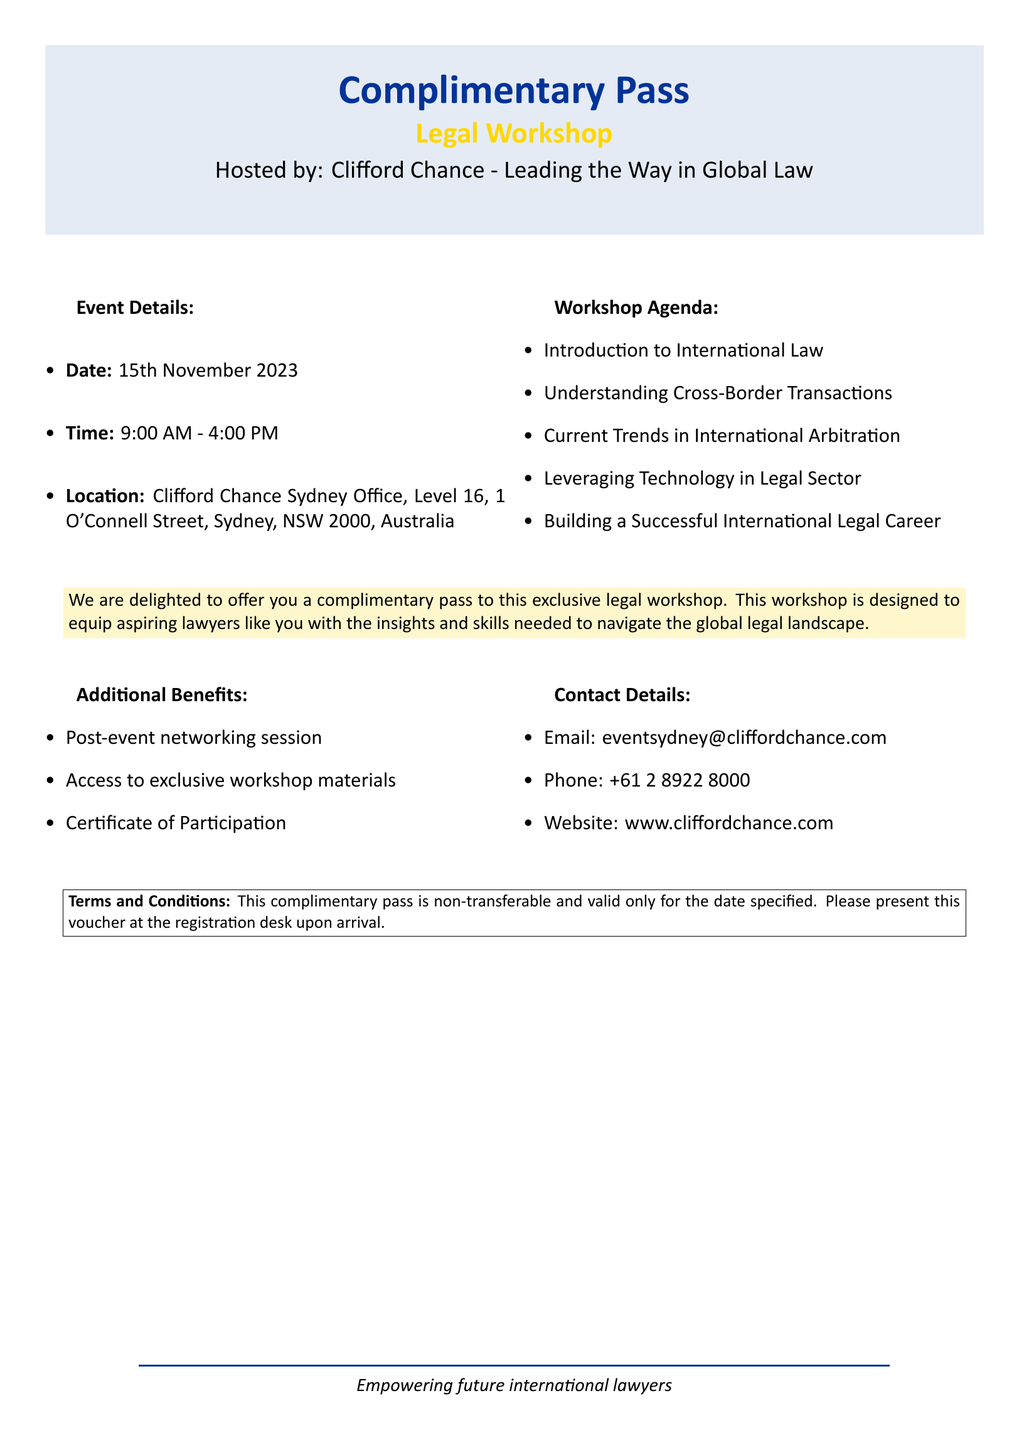What is the date of the workshop? The date of the workshop is specified in the document as 15th November 2023.
Answer: 15th November 2023 What is the time of the event? The document lists the time of the event as 9:00 AM - 4:00 PM.
Answer: 9:00 AM - 4:00 PM Where is the workshop being held? The location provided in the document is Clifford Chance Sydney Office, Level 16, 1 O'Connell Street, Sydney, NSW 2000, Australia.
Answer: Clifford Chance Sydney Office, Level 16, 1 O'Connell Street, Sydney, NSW 2000, Australia Who is hosting the workshop? The document indicates that the workshop is hosted by Clifford Chance.
Answer: Clifford Chance What are the additional benefits included? The document lists that additional benefits include a post-event networking session, access to exclusive workshop materials, and a certificate of participation.
Answer: Post-event networking session, access to exclusive workshop materials, Certificate of Participation What is the purpose of the complimentary pass? The document states that the complimentary pass is designed to equip aspiring lawyers with insights and skills needed to navigate the global legal landscape.
Answer: Equip aspiring lawyers with insights and skills What should be presented at registration? According to the terms and conditions outlined, the document notes that the voucher must be presented at the registration desk upon arrival.
Answer: The voucher What does the complementary pass signify in terms of transferability? The terms and conditions clarify that the complimentary pass is non-transferable, which is a specific restriction mentioned.
Answer: Non-transferable What certificate is offered to participants? The document mentions that a certificate of participation will be provided to participants.
Answer: Certificate of Participation 